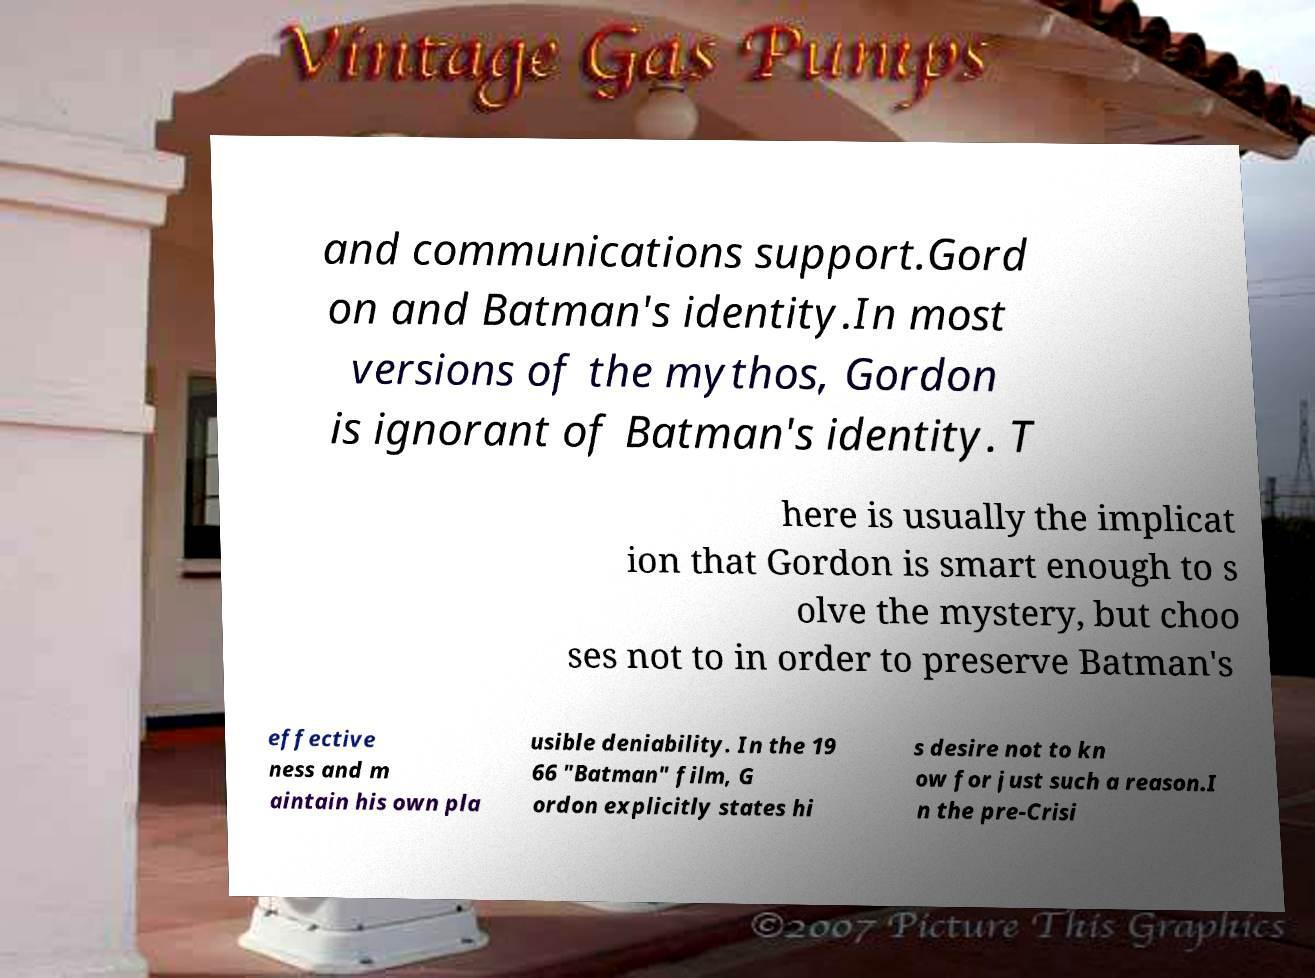Could you assist in decoding the text presented in this image and type it out clearly? and communications support.Gord on and Batman's identity.In most versions of the mythos, Gordon is ignorant of Batman's identity. T here is usually the implicat ion that Gordon is smart enough to s olve the mystery, but choo ses not to in order to preserve Batman's effective ness and m aintain his own pla usible deniability. In the 19 66 "Batman" film, G ordon explicitly states hi s desire not to kn ow for just such a reason.I n the pre-Crisi 